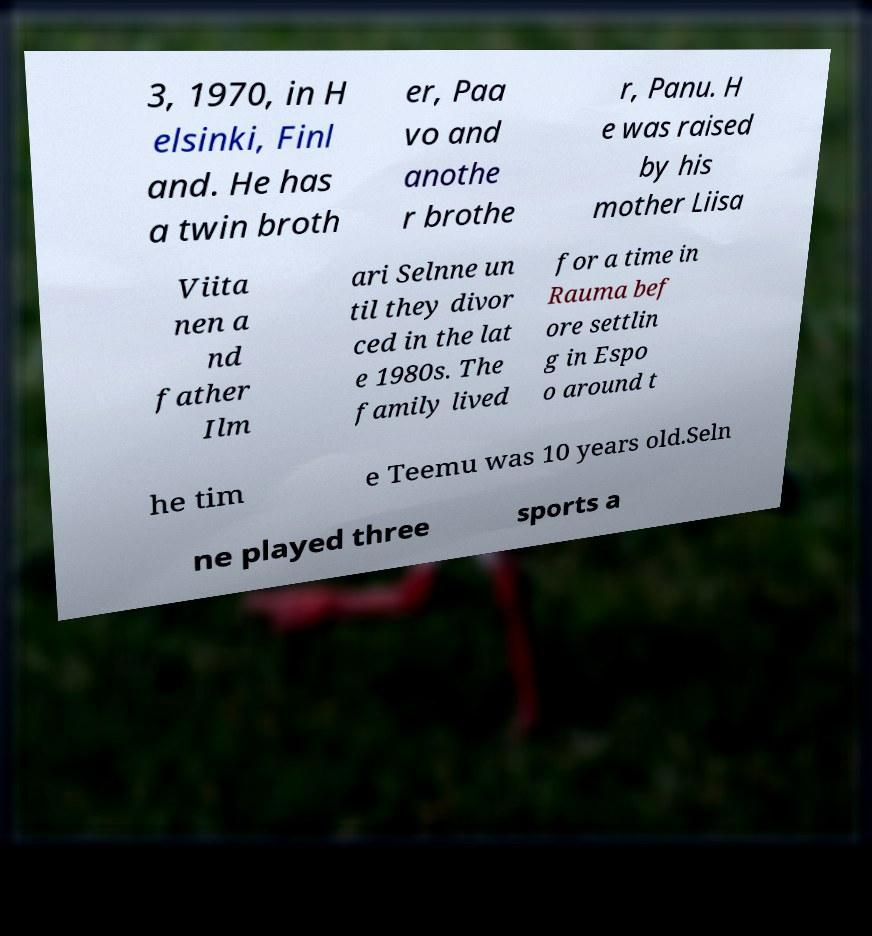I need the written content from this picture converted into text. Can you do that? 3, 1970, in H elsinki, Finl and. He has a twin broth er, Paa vo and anothe r brothe r, Panu. H e was raised by his mother Liisa Viita nen a nd father Ilm ari Selnne un til they divor ced in the lat e 1980s. The family lived for a time in Rauma bef ore settlin g in Espo o around t he tim e Teemu was 10 years old.Seln ne played three sports a 